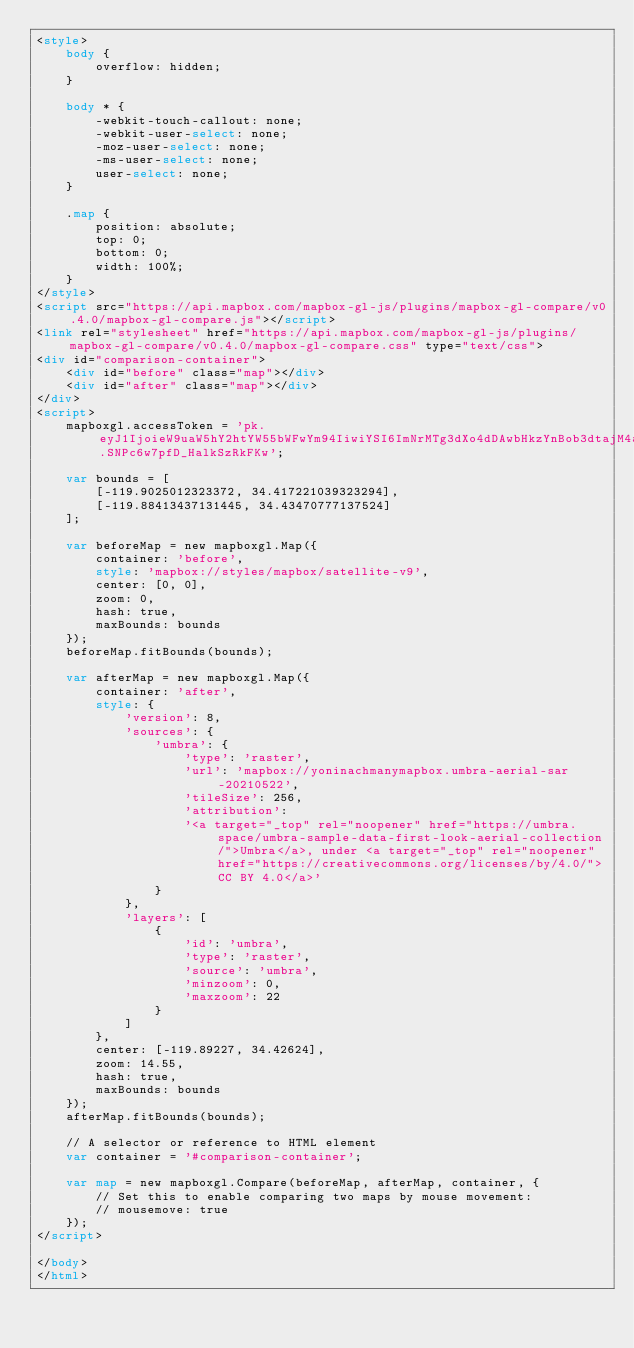<code> <loc_0><loc_0><loc_500><loc_500><_HTML_><style>
    body {
        overflow: hidden;
    }

    body * {
        -webkit-touch-callout: none;
        -webkit-user-select: none;
        -moz-user-select: none;
        -ms-user-select: none;
        user-select: none;
    }

    .map {
        position: absolute;
        top: 0;
        bottom: 0;
        width: 100%;
    }
</style>
<script src="https://api.mapbox.com/mapbox-gl-js/plugins/mapbox-gl-compare/v0.4.0/mapbox-gl-compare.js"></script>
<link rel="stylesheet" href="https://api.mapbox.com/mapbox-gl-js/plugins/mapbox-gl-compare/v0.4.0/mapbox-gl-compare.css" type="text/css">
<div id="comparison-container">
    <div id="before" class="map"></div>
    <div id="after" class="map"></div>
</div>
<script>
    mapboxgl.accessToken = 'pk.eyJ1IjoieW9uaW5hY2htYW55bWFwYm94IiwiYSI6ImNrMTg3dXo4dDAwbHkzYnBob3dtajM4a2kifQ.SNPc6w7pfD_HalkSzRkFKw';

    var bounds = [
        [-119.9025012323372, 34.417221039323294],
        [-119.88413437131445, 34.43470777137524]
    ];

    var beforeMap = new mapboxgl.Map({
        container: 'before',
        style: 'mapbox://styles/mapbox/satellite-v9',
        center: [0, 0],
        zoom: 0,
        hash: true,
        maxBounds: bounds
    });
    beforeMap.fitBounds(bounds);

    var afterMap = new mapboxgl.Map({
        container: 'after',
        style: {
            'version': 8,
            'sources': {
                'umbra': {
                    'type': 'raster',
                    'url': 'mapbox://yoninachmanymapbox.umbra-aerial-sar-20210522',
                    'tileSize': 256,
                    'attribution':
                    '<a target="_top" rel="noopener" href="https://umbra.space/umbra-sample-data-first-look-aerial-collection/">Umbra</a>, under <a target="_top" rel="noopener" href="https://creativecommons.org/licenses/by/4.0/">CC BY 4.0</a>'
                }
            },
            'layers': [
                {
                    'id': 'umbra',
                    'type': 'raster',
                    'source': 'umbra',
                    'minzoom': 0,
                    'maxzoom': 22
                }
            ]
        },
        center: [-119.89227, 34.42624],
        zoom: 14.55,
        hash: true,
        maxBounds: bounds
    });
    afterMap.fitBounds(bounds);

    // A selector or reference to HTML element
    var container = '#comparison-container';

    var map = new mapboxgl.Compare(beforeMap, afterMap, container, {
        // Set this to enable comparing two maps by mouse movement:
        // mousemove: true
    });
</script>

</body>
</html></code> 